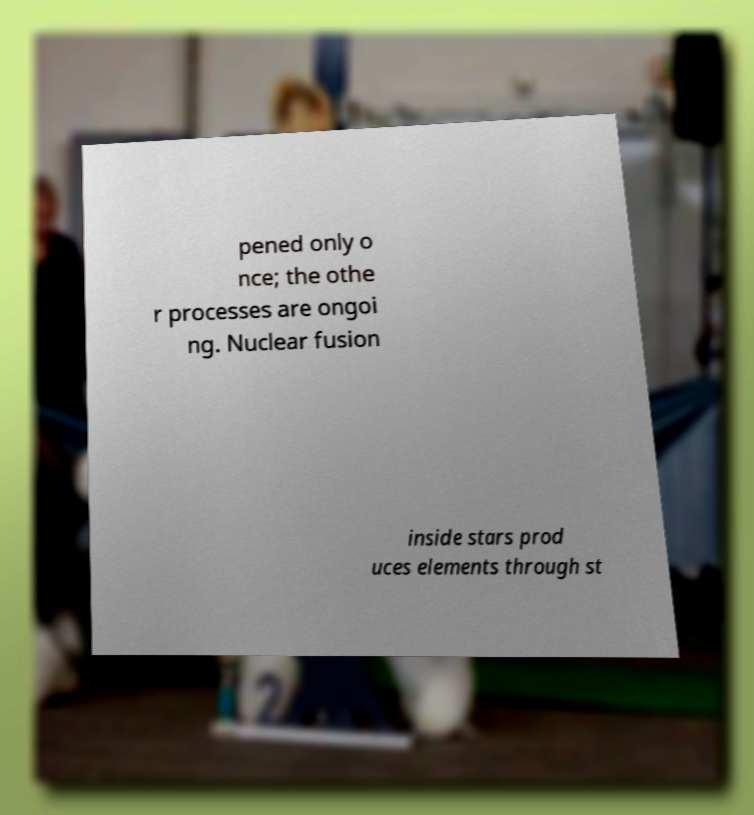There's text embedded in this image that I need extracted. Can you transcribe it verbatim? pened only o nce; the othe r processes are ongoi ng. Nuclear fusion inside stars prod uces elements through st 